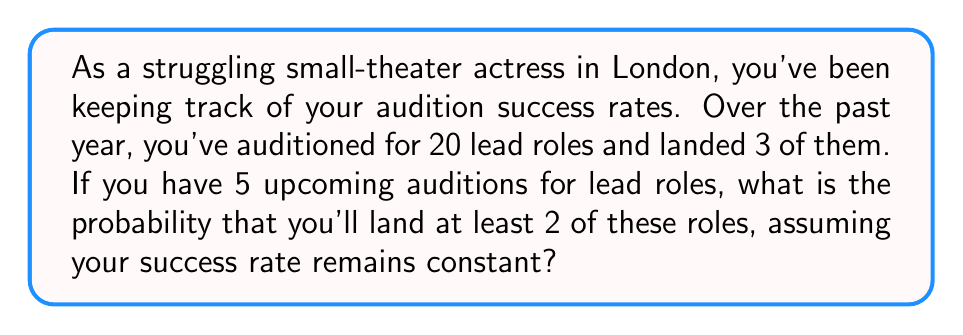Give your solution to this math problem. To solve this problem, we'll use the binomial probability distribution, as we're dealing with a fixed number of independent trials (auditions) with two possible outcomes (success or failure) for each trial.

Let's break it down step-by-step:

1. Calculate the probability of success for a single audition:
   $p = \frac{\text{number of successes}}{\text{total number of auditions}} = \frac{3}{20} = 0.15$

2. The probability of failure for a single audition:
   $q = 1 - p = 1 - 0.15 = 0.85$

3. We want the probability of landing at least 2 out of 5 roles. This means we need to calculate the probability of landing 2, 3, 4, or 5 roles and sum these probabilities.

4. The binomial probability formula is:
   $P(X = k) = \binom{n}{k} p^k q^{n-k}$
   
   Where:
   $n$ = number of trials (5 auditions)
   $k$ = number of successes
   $p$ = probability of success for each trial (0.15)
   $q$ = probability of failure for each trial (0.85)

5. Let's calculate each probability:

   For 2 successes: 
   $P(X = 2) = \binom{5}{2} (0.15)^2 (0.85)^3 = 10 \times 0.0225 \times 0.614125 = 0.138178125$

   For 3 successes:
   $P(X = 3) = \binom{5}{3} (0.15)^3 (0.85)^2 = 10 \times 0.003375 \times 0.7225 = 0.024384375$

   For 4 successes:
   $P(X = 4) = \binom{5}{4} (0.15)^4 (0.85)^1 = 5 \times 0.00050625 \times 0.85 = 0.0021515625$

   For 5 successes:
   $P(X = 5) = \binom{5}{5} (0.15)^5 (0.85)^0 = 1 \times 0.0000759375 \times 1 = 0.0000759375$

6. Sum all these probabilities:
   $P(X \geq 2) = P(X = 2) + P(X = 3) + P(X = 4) + P(X = 5)$
   $= 0.138178125 + 0.024384375 + 0.0021515625 + 0.0000759375$
   $= 0.16479$

Therefore, the probability of landing at least 2 lead roles out of the 5 upcoming auditions is approximately 0.16479 or 16.479%.
Answer: $0.16479$ or $16.479\%$ 